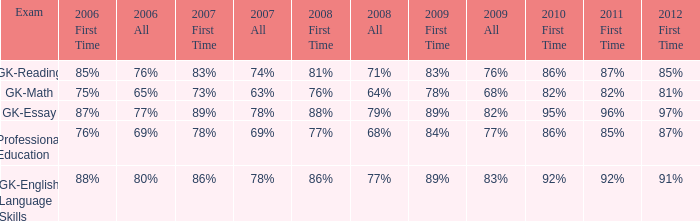What is the percentage for all in 2007 when all in 2006 was 65%? 63%. 